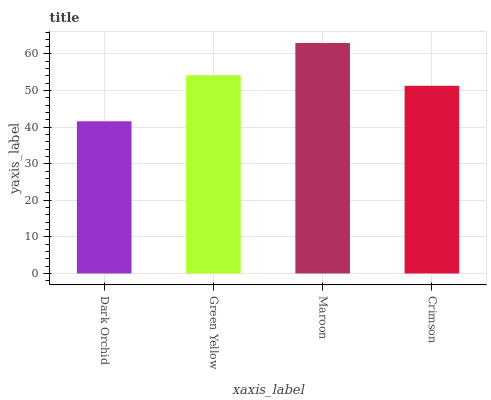Is Dark Orchid the minimum?
Answer yes or no. Yes. Is Maroon the maximum?
Answer yes or no. Yes. Is Green Yellow the minimum?
Answer yes or no. No. Is Green Yellow the maximum?
Answer yes or no. No. Is Green Yellow greater than Dark Orchid?
Answer yes or no. Yes. Is Dark Orchid less than Green Yellow?
Answer yes or no. Yes. Is Dark Orchid greater than Green Yellow?
Answer yes or no. No. Is Green Yellow less than Dark Orchid?
Answer yes or no. No. Is Green Yellow the high median?
Answer yes or no. Yes. Is Crimson the low median?
Answer yes or no. Yes. Is Maroon the high median?
Answer yes or no. No. Is Green Yellow the low median?
Answer yes or no. No. 